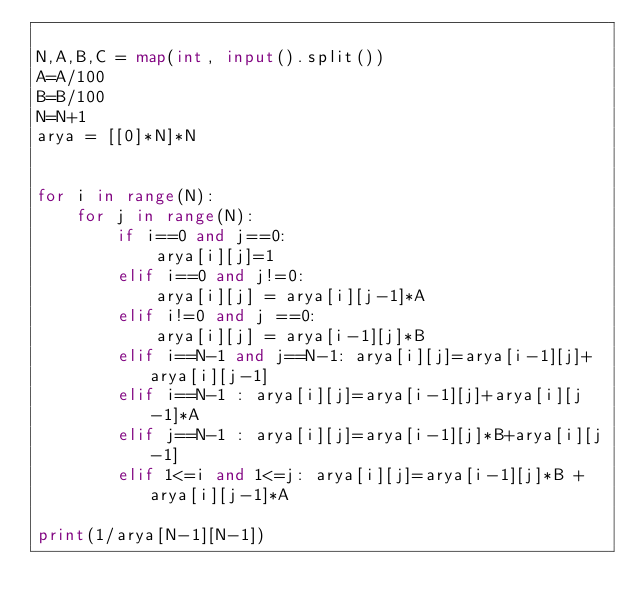Convert code to text. <code><loc_0><loc_0><loc_500><loc_500><_Python_>
N,A,B,C = map(int, input().split())
A=A/100
B=B/100
N=N+1
arya = [[0]*N]*N


for i in range(N):
    for j in range(N):
        if i==0 and j==0:
            arya[i][j]=1
        elif i==0 and j!=0:
            arya[i][j] = arya[i][j-1]*A
        elif i!=0 and j ==0:
            arya[i][j] = arya[i-1][j]*B
        elif i==N-1 and j==N-1: arya[i][j]=arya[i-1][j]+arya[i][j-1]
        elif i==N-1 : arya[i][j]=arya[i-1][j]+arya[i][j-1]*A
        elif j==N-1 : arya[i][j]=arya[i-1][j]*B+arya[i][j-1]
        elif 1<=i and 1<=j: arya[i][j]=arya[i-1][j]*B + arya[i][j-1]*A

print(1/arya[N-1][N-1])
</code> 